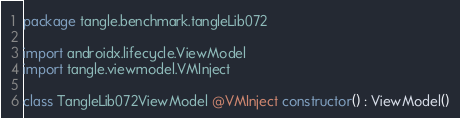Convert code to text. <code><loc_0><loc_0><loc_500><loc_500><_Kotlin_>package tangle.benchmark.tangleLib072

import androidx.lifecycle.ViewModel
import tangle.viewmodel.VMInject

class TangleLib072ViewModel @VMInject constructor() : ViewModel()
</code> 